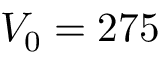<formula> <loc_0><loc_0><loc_500><loc_500>V _ { 0 } = 2 7 5</formula> 